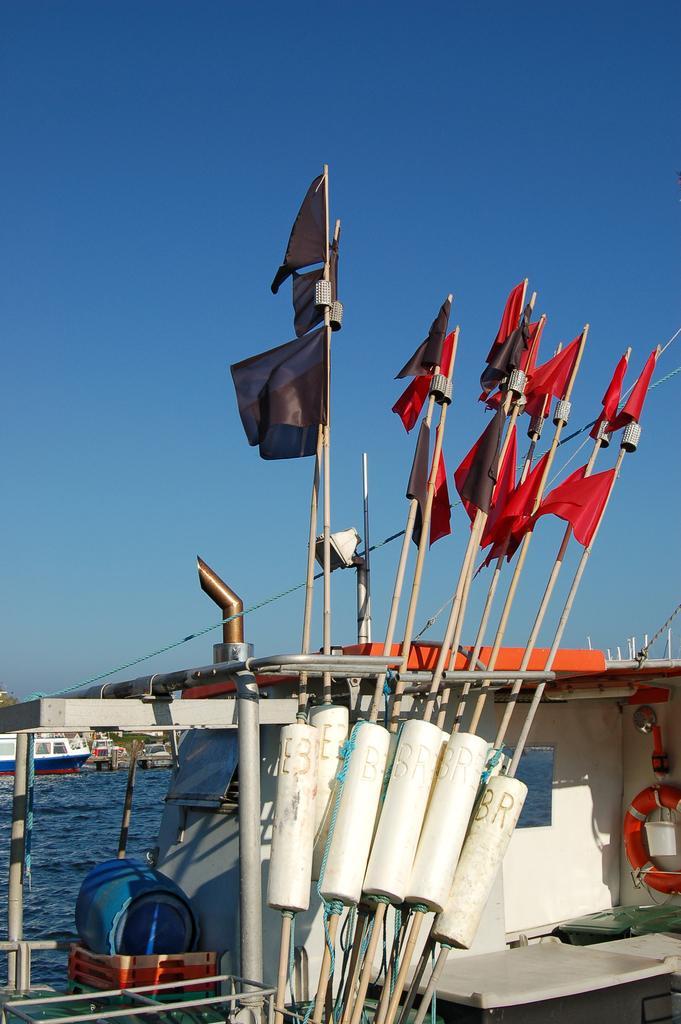Please provide a concise description of this image. In this image there is the sky towards the top of the image, there is the water towards the left of the image, there are boats on the water, there are objects in the boat, there are flags, there is a light, there is a wire. 